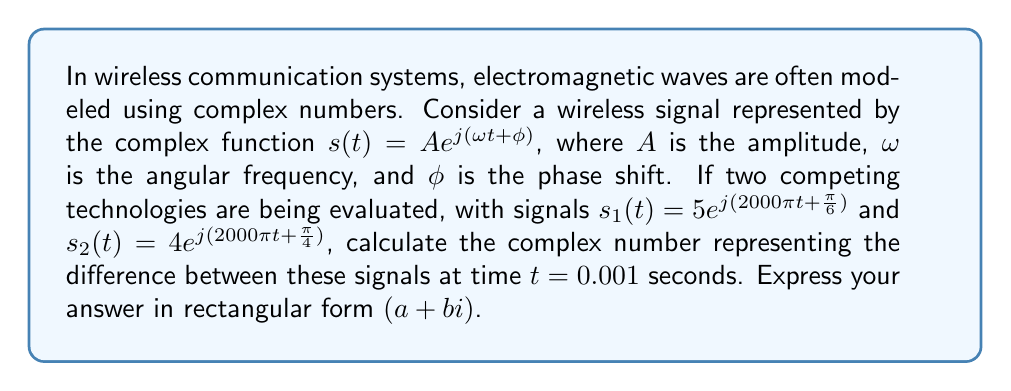Teach me how to tackle this problem. To solve this problem, we'll follow these steps:

1) First, let's evaluate each signal at $t = 0.001$ seconds:

   For $s_1(t)$:
   $$s_1(0.001) = 5e^{j(2000\pi(0.001) + \frac{\pi}{6})}$$
   $$= 5e^{j(2\pi + \frac{\pi}{6})}$$
   $$= 5e^{j(\frac{13\pi}{6})}$$

   For $s_2(t)$:
   $$s_2(0.001) = 4e^{j(2000\pi(0.001) + \frac{\pi}{4})}$$
   $$= 4e^{j(2\pi + \frac{\pi}{4})}$$
   $$= 4e^{j(\frac{9\pi}{4})}$$

2) Now, we need to subtract $s_2(0.001)$ from $s_1(0.001)$:

   $$s_1(0.001) - s_2(0.001) = 5e^{j(\frac{13\pi}{6})} - 4e^{j(\frac{9\pi}{4})}$$

3) To subtract these complex numbers, we need to convert them to rectangular form. We can use Euler's formula: $e^{j\theta} = \cos\theta + j\sin\theta$

   For $s_1(0.001)$:
   $$5e^{j(\frac{13\pi}{6})} = 5(\cos(\frac{13\pi}{6}) + j\sin(\frac{13\pi}{6}))$$
   $$= 5(\frac{\sqrt{3}}{2} - j\frac{1}{2})$$
   $$= \frac{5\sqrt{3}}{2} - j\frac{5}{2}$$

   For $s_2(0.001)$:
   $$4e^{j(\frac{9\pi}{4})} = 4(\cos(\frac{9\pi}{4}) + j\sin(\frac{9\pi}{4}))$$
   $$= 4(-\frac{\sqrt{2}}{2} + j\frac{\sqrt{2}}{2})$$
   $$= -2\sqrt{2} + j2\sqrt{2}$$

4) Now we can subtract:

   $$(\frac{5\sqrt{3}}{2} - j\frac{5}{2}) - (-2\sqrt{2} + j2\sqrt{2})$$
   $$= \frac{5\sqrt{3}}{2} + 2\sqrt{2} + j(-\frac{5}{2} - 2\sqrt{2})$$

5) Simplify:

   $$= (\frac{5\sqrt{3}}{2} + 2\sqrt{2}) + j(-\frac{5}{2} - 2\sqrt{2})$$

This is our final answer in rectangular form $(a + bi)$.
Answer: $(\frac{5\sqrt{3}}{2} + 2\sqrt{2}) + j(-\frac{5}{2} - 2\sqrt{2})$ 